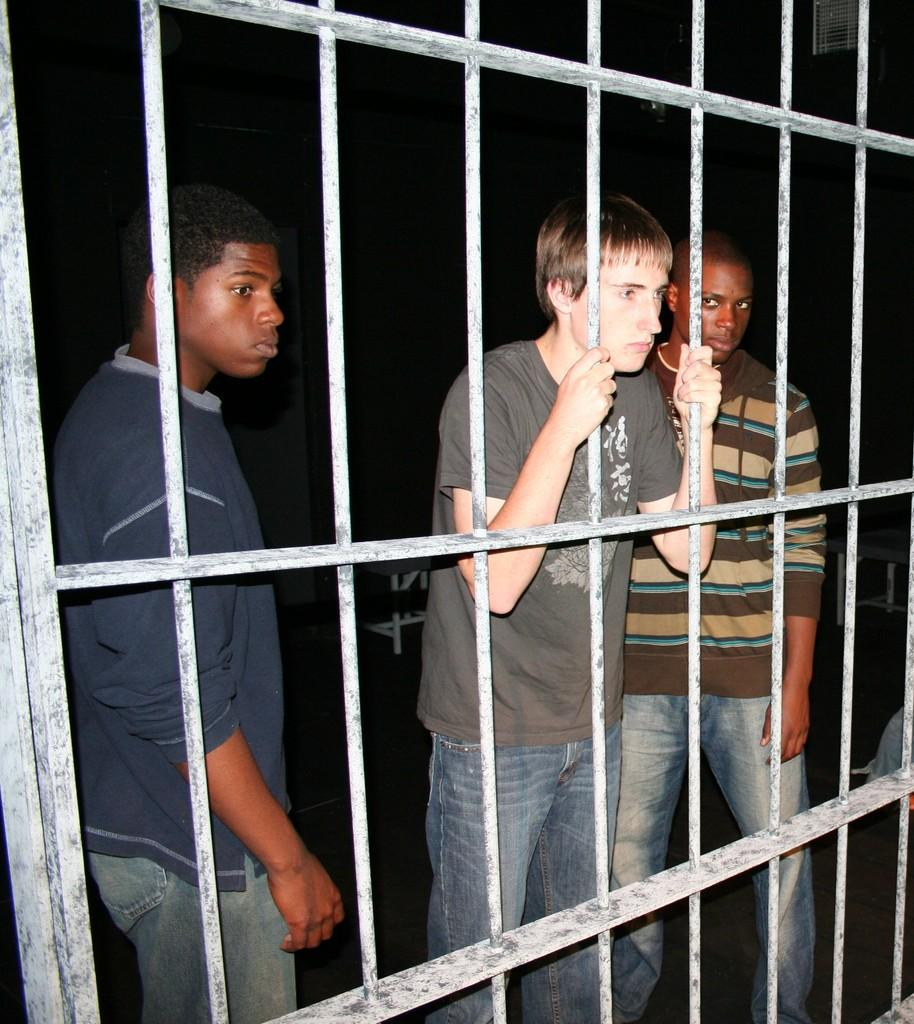How many people are in the image? There are three men in the image. What is the situation of the men in the image? The men are behind bars. What can be observed about the lighting in the image? The background of the image is dark. What is the man on the right side of the image holding? The man on the right side of the image is holding rods. How many sisters are present in the image? There are no sisters mentioned or visible in the image. What type of shoe can be seen on the man holding rods? There is no shoe visible on the man holding rods in the image. 